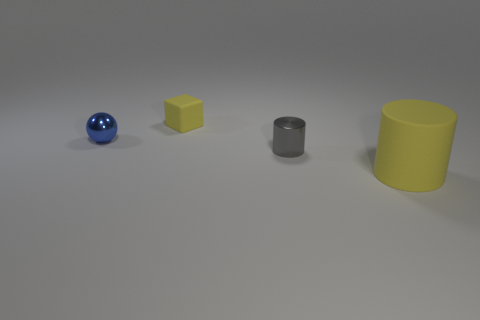There is a big object; how many cylinders are behind it?
Your response must be concise. 1. What color is the cylinder that is made of the same material as the small yellow thing?
Keep it short and to the point. Yellow. Does the gray metallic cylinder have the same size as the object that is on the right side of the small gray metallic cylinder?
Keep it short and to the point. No. What is the size of the yellow object on the right side of the yellow thing that is behind the cylinder behind the yellow cylinder?
Offer a very short reply. Large. What number of rubber things are small red blocks or tiny cylinders?
Give a very brief answer. 0. What color is the matte object in front of the yellow matte cube?
Your answer should be compact. Yellow. What shape is the matte thing that is the same size as the gray shiny thing?
Offer a very short reply. Cube. Is the color of the tiny metallic ball the same as the rubber object that is to the left of the tiny gray shiny thing?
Provide a short and direct response. No. How many things are yellow things that are in front of the metallic cylinder or small objects behind the gray metallic cylinder?
Your answer should be very brief. 3. There is a cylinder that is the same size as the blue metallic ball; what is it made of?
Offer a terse response. Metal. 